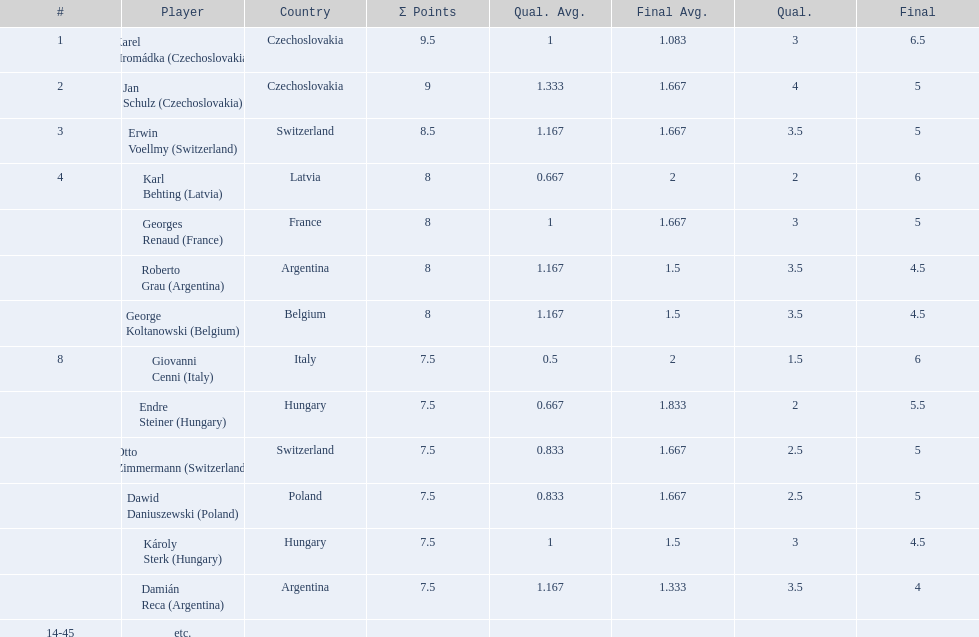How many countries had more than one player in the consolation cup? 4. 